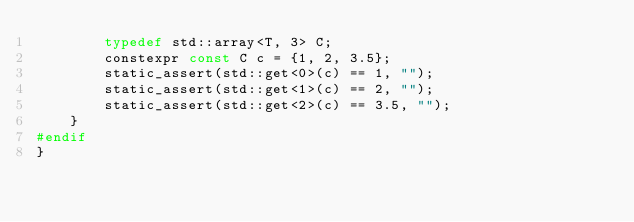<code> <loc_0><loc_0><loc_500><loc_500><_C++_>        typedef std::array<T, 3> C;
        constexpr const C c = {1, 2, 3.5};
        static_assert(std::get<0>(c) == 1, "");
        static_assert(std::get<1>(c) == 2, "");
        static_assert(std::get<2>(c) == 3.5, "");
    }
#endif
}
</code> 